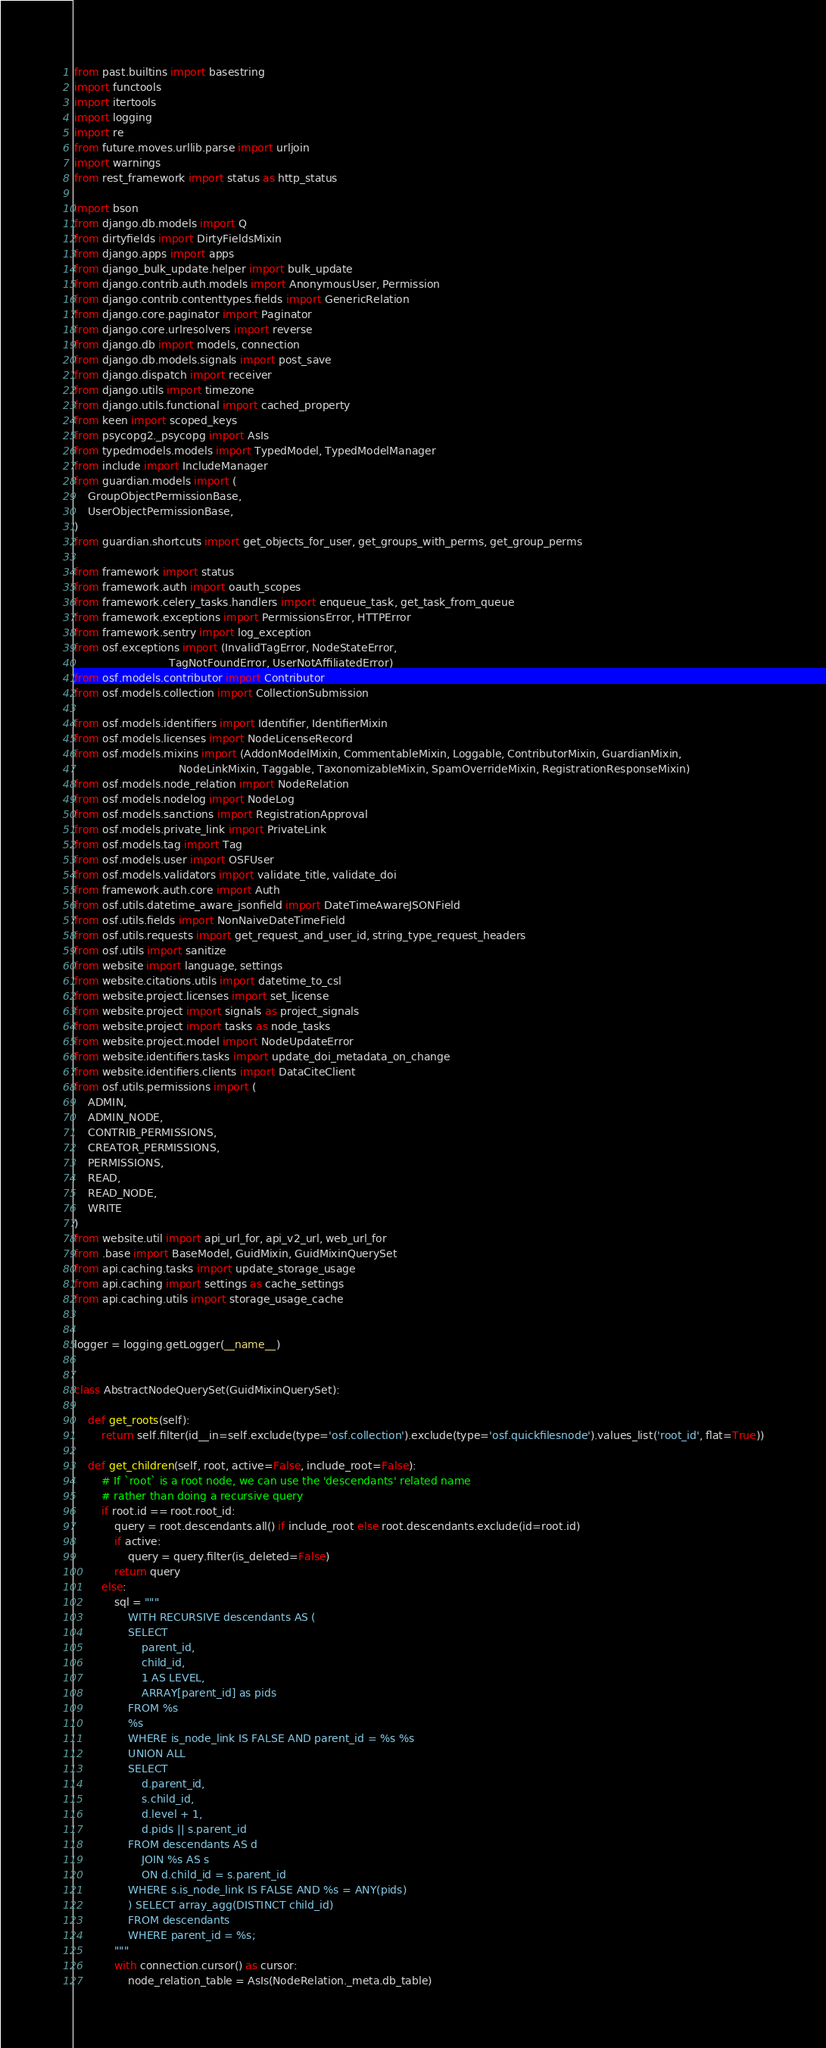Convert code to text. <code><loc_0><loc_0><loc_500><loc_500><_Python_>from past.builtins import basestring
import functools
import itertools
import logging
import re
from future.moves.urllib.parse import urljoin
import warnings
from rest_framework import status as http_status

import bson
from django.db.models import Q
from dirtyfields import DirtyFieldsMixin
from django.apps import apps
from django_bulk_update.helper import bulk_update
from django.contrib.auth.models import AnonymousUser, Permission
from django.contrib.contenttypes.fields import GenericRelation
from django.core.paginator import Paginator
from django.core.urlresolvers import reverse
from django.db import models, connection
from django.db.models.signals import post_save
from django.dispatch import receiver
from django.utils import timezone
from django.utils.functional import cached_property
from keen import scoped_keys
from psycopg2._psycopg import AsIs
from typedmodels.models import TypedModel, TypedModelManager
from include import IncludeManager
from guardian.models import (
    GroupObjectPermissionBase,
    UserObjectPermissionBase,
)
from guardian.shortcuts import get_objects_for_user, get_groups_with_perms, get_group_perms

from framework import status
from framework.auth import oauth_scopes
from framework.celery_tasks.handlers import enqueue_task, get_task_from_queue
from framework.exceptions import PermissionsError, HTTPError
from framework.sentry import log_exception
from osf.exceptions import (InvalidTagError, NodeStateError,
                            TagNotFoundError, UserNotAffiliatedError)
from osf.models.contributor import Contributor
from osf.models.collection import CollectionSubmission

from osf.models.identifiers import Identifier, IdentifierMixin
from osf.models.licenses import NodeLicenseRecord
from osf.models.mixins import (AddonModelMixin, CommentableMixin, Loggable, ContributorMixin, GuardianMixin,
                               NodeLinkMixin, Taggable, TaxonomizableMixin, SpamOverrideMixin, RegistrationResponseMixin)
from osf.models.node_relation import NodeRelation
from osf.models.nodelog import NodeLog
from osf.models.sanctions import RegistrationApproval
from osf.models.private_link import PrivateLink
from osf.models.tag import Tag
from osf.models.user import OSFUser
from osf.models.validators import validate_title, validate_doi
from framework.auth.core import Auth
from osf.utils.datetime_aware_jsonfield import DateTimeAwareJSONField
from osf.utils.fields import NonNaiveDateTimeField
from osf.utils.requests import get_request_and_user_id, string_type_request_headers
from osf.utils import sanitize
from website import language, settings
from website.citations.utils import datetime_to_csl
from website.project.licenses import set_license
from website.project import signals as project_signals
from website.project import tasks as node_tasks
from website.project.model import NodeUpdateError
from website.identifiers.tasks import update_doi_metadata_on_change
from website.identifiers.clients import DataCiteClient
from osf.utils.permissions import (
    ADMIN,
    ADMIN_NODE,
    CONTRIB_PERMISSIONS,
    CREATOR_PERMISSIONS,
    PERMISSIONS,
    READ,
    READ_NODE,
    WRITE
)
from website.util import api_url_for, api_v2_url, web_url_for
from .base import BaseModel, GuidMixin, GuidMixinQuerySet
from api.caching.tasks import update_storage_usage
from api.caching import settings as cache_settings
from api.caching.utils import storage_usage_cache


logger = logging.getLogger(__name__)


class AbstractNodeQuerySet(GuidMixinQuerySet):

    def get_roots(self):
        return self.filter(id__in=self.exclude(type='osf.collection').exclude(type='osf.quickfilesnode').values_list('root_id', flat=True))

    def get_children(self, root, active=False, include_root=False):
        # If `root` is a root node, we can use the 'descendants' related name
        # rather than doing a recursive query
        if root.id == root.root_id:
            query = root.descendants.all() if include_root else root.descendants.exclude(id=root.id)
            if active:
                query = query.filter(is_deleted=False)
            return query
        else:
            sql = """
                WITH RECURSIVE descendants AS (
                SELECT
                    parent_id,
                    child_id,
                    1 AS LEVEL,
                    ARRAY[parent_id] as pids
                FROM %s
                %s
                WHERE is_node_link IS FALSE AND parent_id = %s %s
                UNION ALL
                SELECT
                    d.parent_id,
                    s.child_id,
                    d.level + 1,
                    d.pids || s.parent_id
                FROM descendants AS d
                    JOIN %s AS s
                    ON d.child_id = s.parent_id
                WHERE s.is_node_link IS FALSE AND %s = ANY(pids)
                ) SELECT array_agg(DISTINCT child_id)
                FROM descendants
                WHERE parent_id = %s;
            """
            with connection.cursor() as cursor:
                node_relation_table = AsIs(NodeRelation._meta.db_table)</code> 